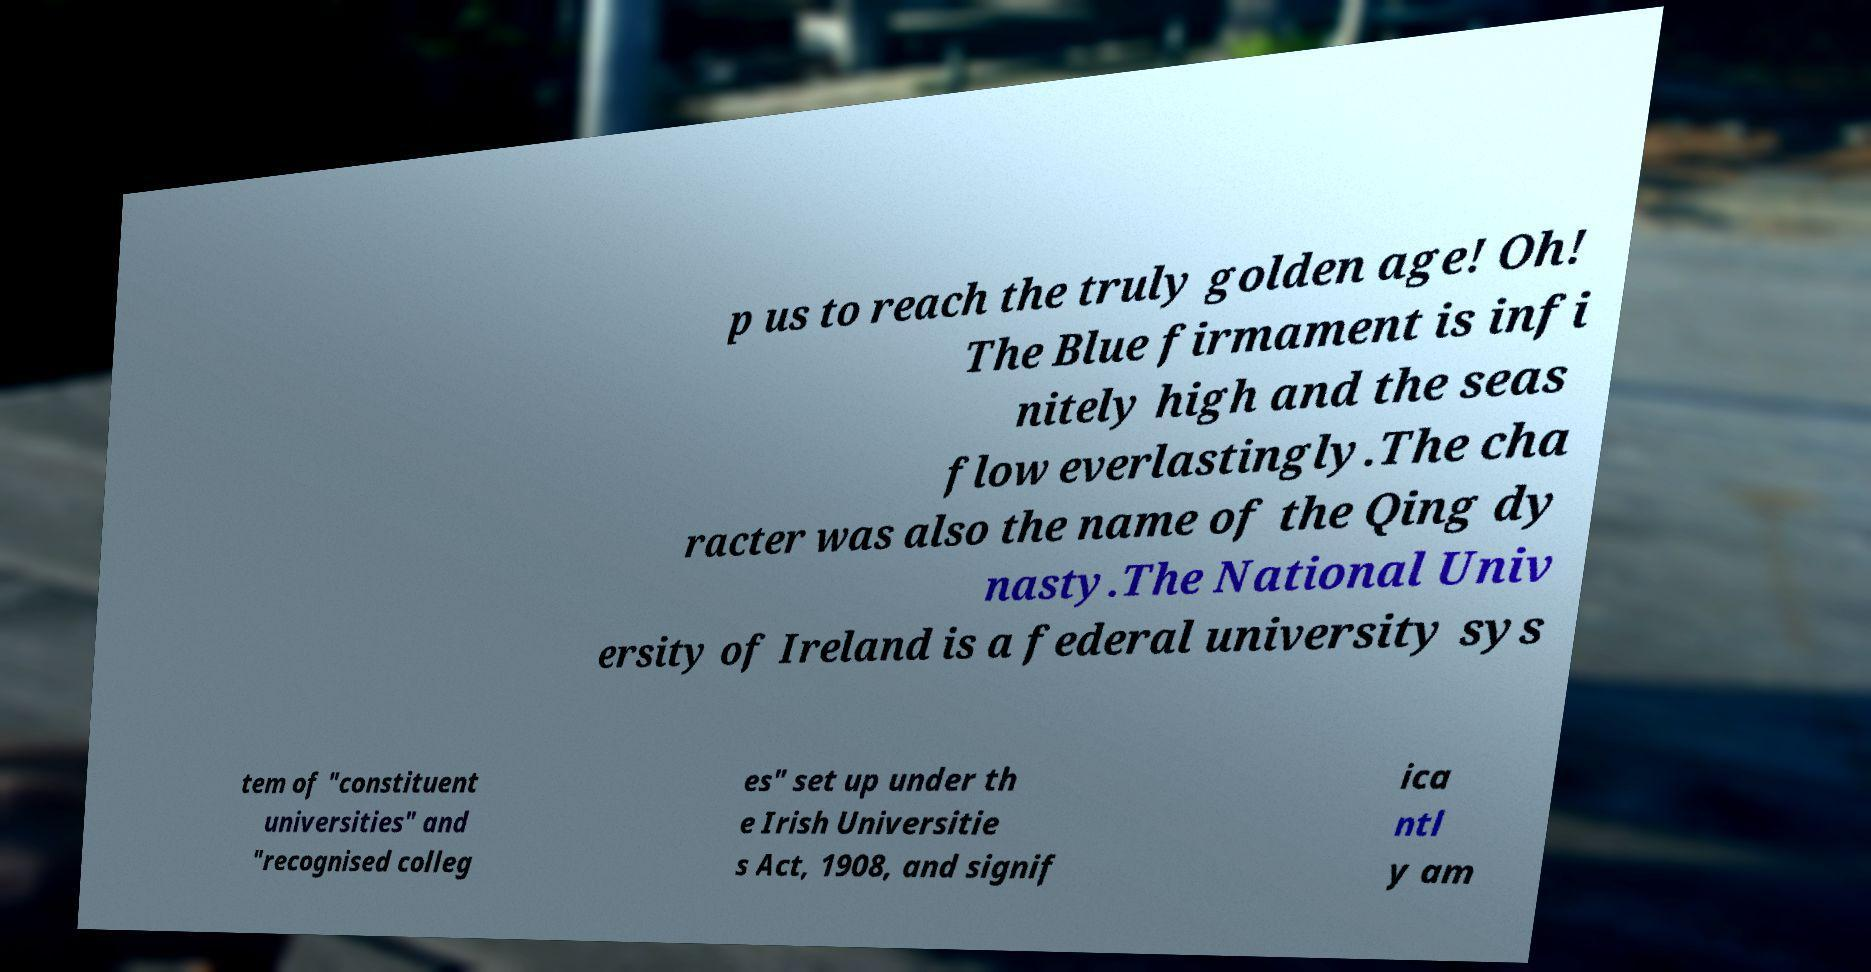Please identify and transcribe the text found in this image. p us to reach the truly golden age! Oh! The Blue firmament is infi nitely high and the seas flow everlastingly.The cha racter was also the name of the Qing dy nasty.The National Univ ersity of Ireland is a federal university sys tem of "constituent universities" and "recognised colleg es" set up under th e Irish Universitie s Act, 1908, and signif ica ntl y am 